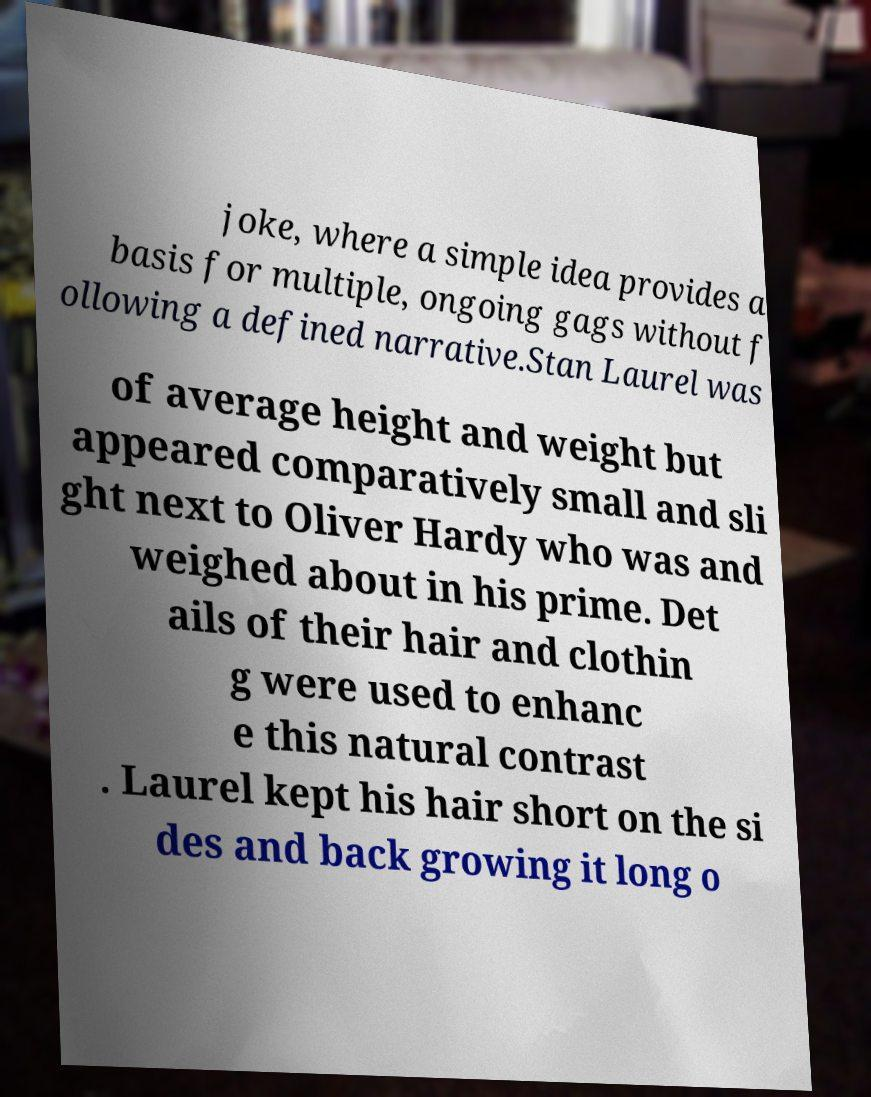Please identify and transcribe the text found in this image. joke, where a simple idea provides a basis for multiple, ongoing gags without f ollowing a defined narrative.Stan Laurel was of average height and weight but appeared comparatively small and sli ght next to Oliver Hardy who was and weighed about in his prime. Det ails of their hair and clothin g were used to enhanc e this natural contrast . Laurel kept his hair short on the si des and back growing it long o 